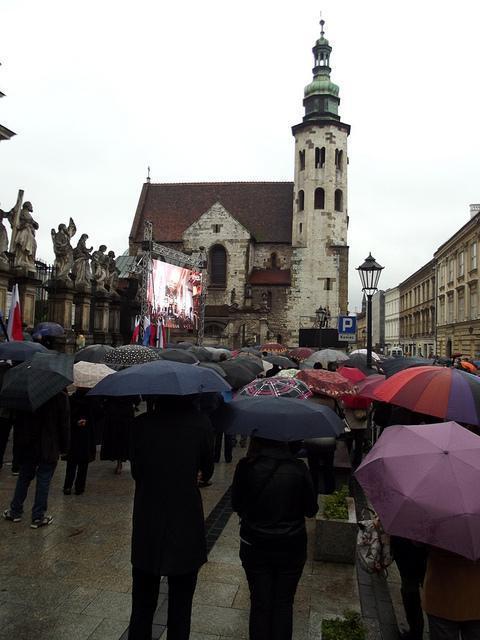How many people are there?
Give a very brief answer. 6. How many umbrellas are there?
Give a very brief answer. 5. How many slats make up the bench seat?
Give a very brief answer. 0. 